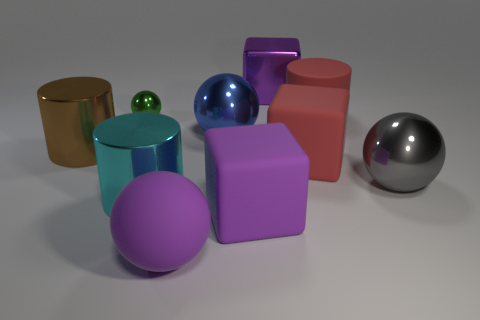Can you describe the textures that appear in the objects within the image? Certainly! The objects in the image have a variety of textures. The spheres and the taller cylinder have a glossy finish which reflects the light, giving them a shiny appearance. The cubes and the shorter cylinder have a matte finish with less reflection, providing a contrast to the shiny surfaces around them. 